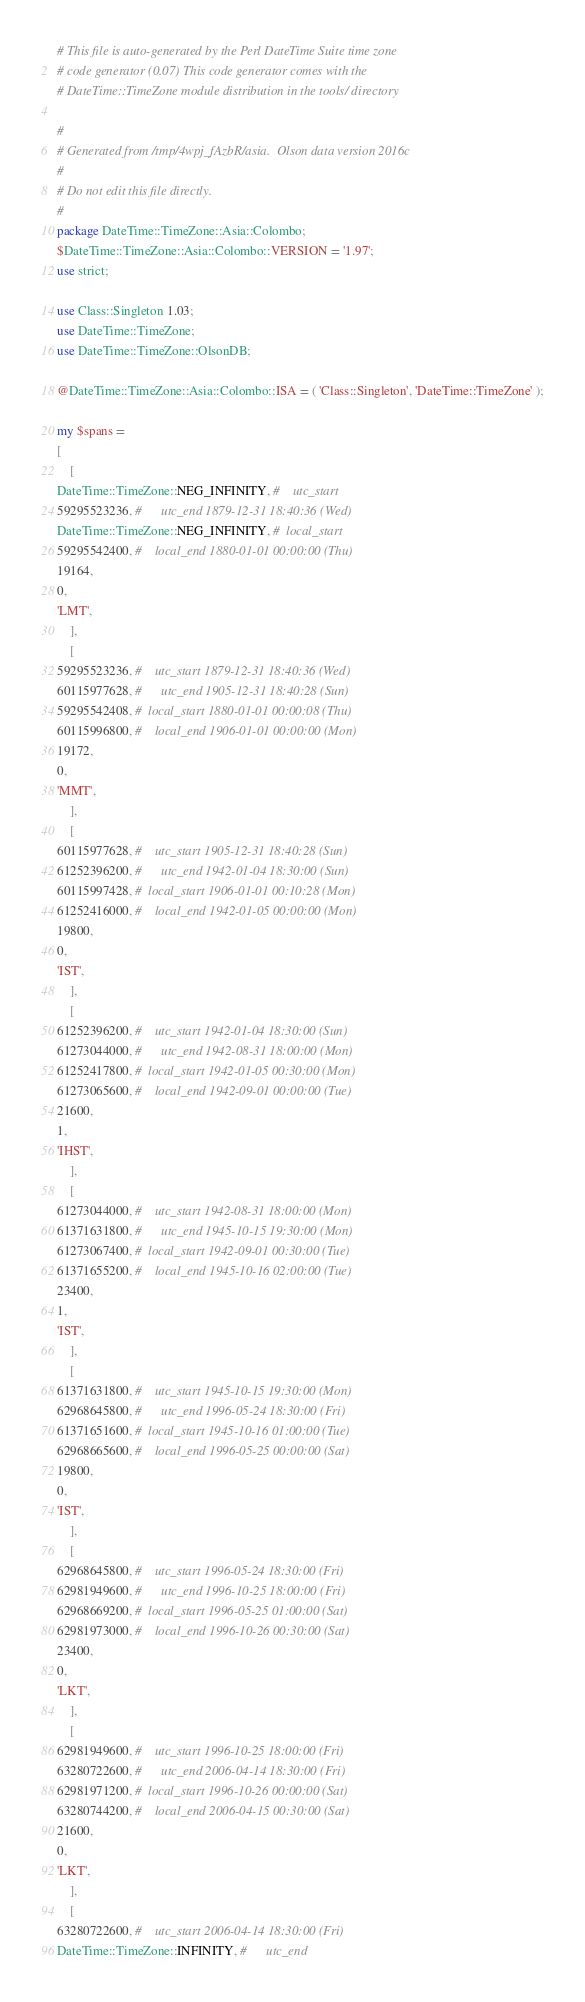<code> <loc_0><loc_0><loc_500><loc_500><_Perl_># This file is auto-generated by the Perl DateTime Suite time zone
# code generator (0.07) This code generator comes with the
# DateTime::TimeZone module distribution in the tools/ directory

#
# Generated from /tmp/4wpj_fAzbR/asia.  Olson data version 2016c
#
# Do not edit this file directly.
#
package DateTime::TimeZone::Asia::Colombo;
$DateTime::TimeZone::Asia::Colombo::VERSION = '1.97';
use strict;

use Class::Singleton 1.03;
use DateTime::TimeZone;
use DateTime::TimeZone::OlsonDB;

@DateTime::TimeZone::Asia::Colombo::ISA = ( 'Class::Singleton', 'DateTime::TimeZone' );

my $spans =
[
    [
DateTime::TimeZone::NEG_INFINITY, #    utc_start
59295523236, #      utc_end 1879-12-31 18:40:36 (Wed)
DateTime::TimeZone::NEG_INFINITY, #  local_start
59295542400, #    local_end 1880-01-01 00:00:00 (Thu)
19164,
0,
'LMT',
    ],
    [
59295523236, #    utc_start 1879-12-31 18:40:36 (Wed)
60115977628, #      utc_end 1905-12-31 18:40:28 (Sun)
59295542408, #  local_start 1880-01-01 00:00:08 (Thu)
60115996800, #    local_end 1906-01-01 00:00:00 (Mon)
19172,
0,
'MMT',
    ],
    [
60115977628, #    utc_start 1905-12-31 18:40:28 (Sun)
61252396200, #      utc_end 1942-01-04 18:30:00 (Sun)
60115997428, #  local_start 1906-01-01 00:10:28 (Mon)
61252416000, #    local_end 1942-01-05 00:00:00 (Mon)
19800,
0,
'IST',
    ],
    [
61252396200, #    utc_start 1942-01-04 18:30:00 (Sun)
61273044000, #      utc_end 1942-08-31 18:00:00 (Mon)
61252417800, #  local_start 1942-01-05 00:30:00 (Mon)
61273065600, #    local_end 1942-09-01 00:00:00 (Tue)
21600,
1,
'IHST',
    ],
    [
61273044000, #    utc_start 1942-08-31 18:00:00 (Mon)
61371631800, #      utc_end 1945-10-15 19:30:00 (Mon)
61273067400, #  local_start 1942-09-01 00:30:00 (Tue)
61371655200, #    local_end 1945-10-16 02:00:00 (Tue)
23400,
1,
'IST',
    ],
    [
61371631800, #    utc_start 1945-10-15 19:30:00 (Mon)
62968645800, #      utc_end 1996-05-24 18:30:00 (Fri)
61371651600, #  local_start 1945-10-16 01:00:00 (Tue)
62968665600, #    local_end 1996-05-25 00:00:00 (Sat)
19800,
0,
'IST',
    ],
    [
62968645800, #    utc_start 1996-05-24 18:30:00 (Fri)
62981949600, #      utc_end 1996-10-25 18:00:00 (Fri)
62968669200, #  local_start 1996-05-25 01:00:00 (Sat)
62981973000, #    local_end 1996-10-26 00:30:00 (Sat)
23400,
0,
'LKT',
    ],
    [
62981949600, #    utc_start 1996-10-25 18:00:00 (Fri)
63280722600, #      utc_end 2006-04-14 18:30:00 (Fri)
62981971200, #  local_start 1996-10-26 00:00:00 (Sat)
63280744200, #    local_end 2006-04-15 00:30:00 (Sat)
21600,
0,
'LKT',
    ],
    [
63280722600, #    utc_start 2006-04-14 18:30:00 (Fri)
DateTime::TimeZone::INFINITY, #      utc_end</code> 